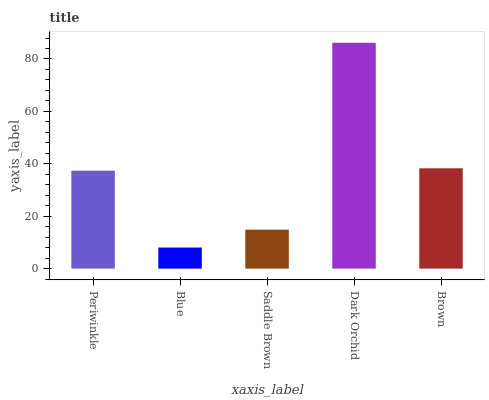Is Saddle Brown the minimum?
Answer yes or no. No. Is Saddle Brown the maximum?
Answer yes or no. No. Is Saddle Brown greater than Blue?
Answer yes or no. Yes. Is Blue less than Saddle Brown?
Answer yes or no. Yes. Is Blue greater than Saddle Brown?
Answer yes or no. No. Is Saddle Brown less than Blue?
Answer yes or no. No. Is Periwinkle the high median?
Answer yes or no. Yes. Is Periwinkle the low median?
Answer yes or no. Yes. Is Saddle Brown the high median?
Answer yes or no. No. Is Dark Orchid the low median?
Answer yes or no. No. 